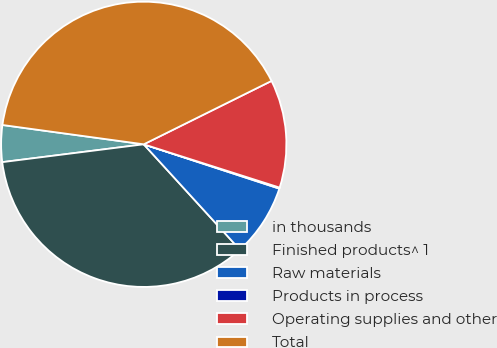Convert chart to OTSL. <chart><loc_0><loc_0><loc_500><loc_500><pie_chart><fcel>in thousands<fcel>Finished products^ 1<fcel>Raw materials<fcel>Products in process<fcel>Operating supplies and other<fcel>Total<nl><fcel>4.16%<fcel>34.78%<fcel>8.2%<fcel>0.12%<fcel>12.24%<fcel>40.51%<nl></chart> 